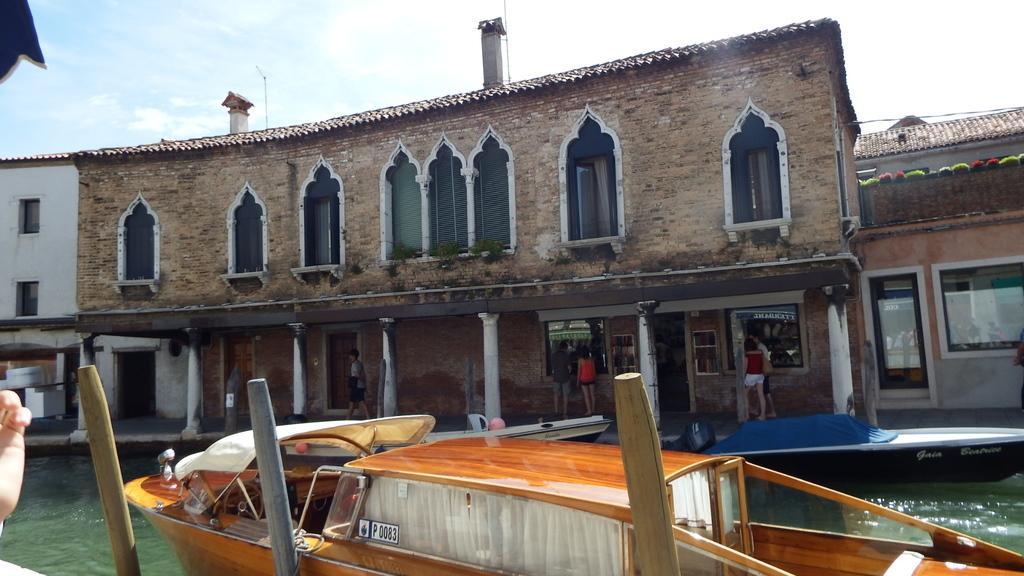Could you give a brief overview of what you see in this image? In the foreground I can see boats in the water. In the background I can see buildings, pillars, group of people on the road, windows, door, houseplants and the sky. This image is taken, may be during a day. 